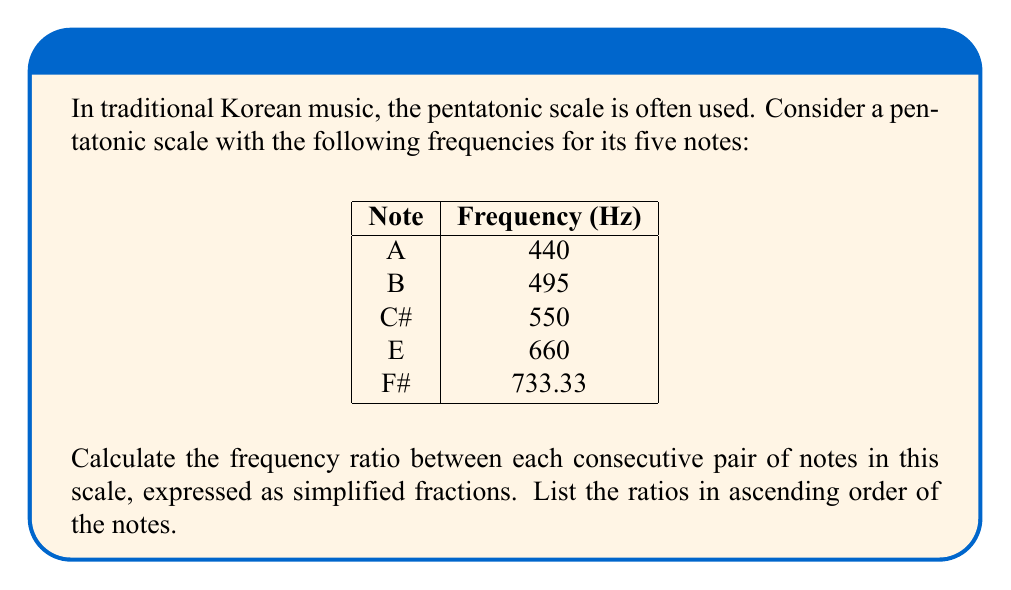Provide a solution to this math problem. To calculate the frequency ratios between consecutive notes, we'll divide the frequency of each note by the frequency of the note preceding it. Then, we'll simplify these fractions.

1. Ratio between A and B:
   $\frac{495}{440} = \frac{9}{8}$

2. Ratio between B and C#:
   $\frac{550}{495} = \frac{10}{9}$

3. Ratio between C# and E:
   $\frac{660}{550} = \frac{6}{5}$

4. Ratio between E and F#:
   $\frac{733.33}{660} \approx \frac{10}{9}$

To simplify these fractions:
- $\frac{495}{440} = \frac{9}{8}$ (already simplified)
- $\frac{550}{495} = \frac{10}{9}$ (already simplified)
- $\frac{660}{550} = \frac{6}{5}$ (already simplified)
- $\frac{733.33}{660} \approx \frac{10}{9}$ (approximation, already simplified)

Listing the ratios in ascending order of the notes:

1. A to B: $\frac{9}{8}$
2. B to C#: $\frac{10}{9}$
3. C# to E: $\frac{6}{5}$
4. E to F#: $\frac{10}{9}$
Answer: $\frac{9}{8}, \frac{10}{9}, \frac{6}{5}, \frac{10}{9}$ 